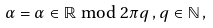<formula> <loc_0><loc_0><loc_500><loc_500>\alpha = \alpha \in \mathbb { R } \bmod { 2 \pi q } \, , q \in \mathbb { N } \, ,</formula> 